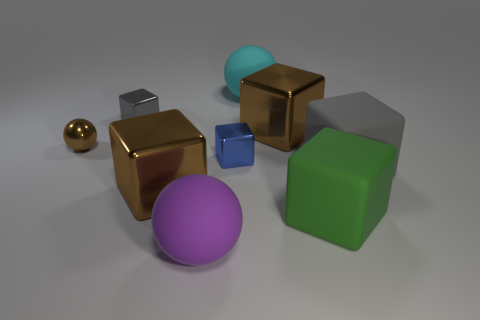What shape is the cyan rubber thing that is the same size as the purple matte object?
Ensure brevity in your answer.  Sphere. There is a large block in front of the brown block that is in front of the block right of the green thing; what is it made of?
Your response must be concise. Rubber. There is a brown metal object that is the same shape as the large cyan matte thing; what size is it?
Your answer should be very brief. Small. What is the size of the metal object that is both left of the large cyan rubber ball and right of the purple ball?
Provide a short and direct response. Small. How many objects are small metallic cubes that are right of the purple matte thing or big gray matte things?
Give a very brief answer. 2. How many cyan rubber spheres are in front of the small shiny cube that is to the left of the small blue metallic block?
Provide a succinct answer. 0. Is the number of blocks right of the purple rubber object less than the number of big objects that are on the left side of the brown metallic ball?
Your answer should be compact. No. The purple object that is left of the gray object to the right of the large green block is what shape?
Your response must be concise. Sphere. How many other objects are there of the same material as the tiny gray cube?
Make the answer very short. 4. Is there any other thing that is the same size as the purple object?
Ensure brevity in your answer.  Yes. 